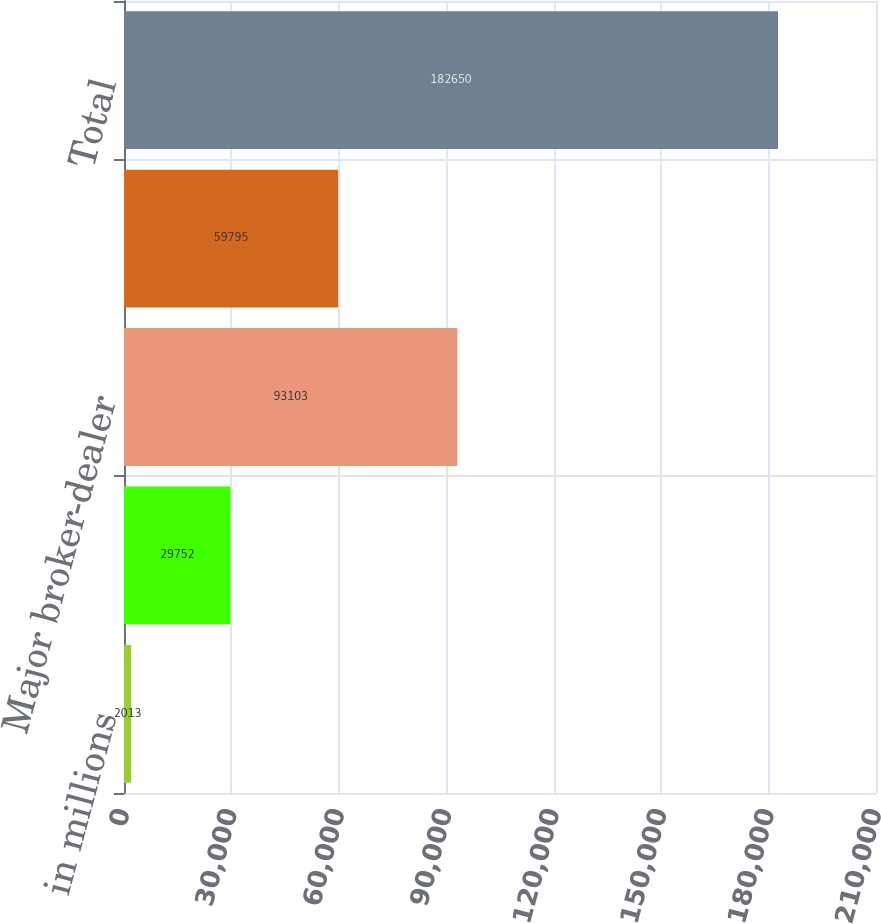<chart> <loc_0><loc_0><loc_500><loc_500><bar_chart><fcel>in millions<fcel>Group Inc<fcel>Major broker-dealer<fcel>Major bank subsidiaries<fcel>Total<nl><fcel>2013<fcel>29752<fcel>93103<fcel>59795<fcel>182650<nl></chart> 